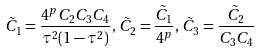Convert formula to latex. <formula><loc_0><loc_0><loc_500><loc_500>\tilde { C } _ { 1 } = \frac { 4 ^ { p } C _ { 2 } C _ { 3 } C _ { 4 } } { \tau ^ { 2 } ( 1 - \tau ^ { 2 } ) } , \, \tilde { C } _ { 2 } = \frac { \tilde { C } _ { 1 } } { 4 ^ { p } } , \, \tilde { C } _ { 3 } = \frac { \tilde { C } _ { 2 } } { C _ { 3 } C _ { 4 } }</formula> 